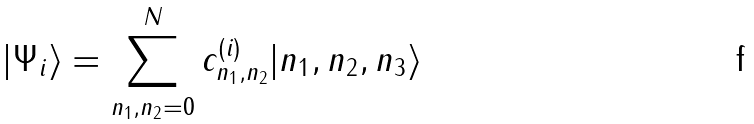<formula> <loc_0><loc_0><loc_500><loc_500>| \Psi _ { i } \rangle = \sum _ { n _ { 1 } , n _ { 2 } = 0 } ^ { N } c _ { n _ { 1 } , n _ { 2 } } ^ { ( i ) } | n _ { 1 } , n _ { 2 } , n _ { 3 } \rangle</formula> 